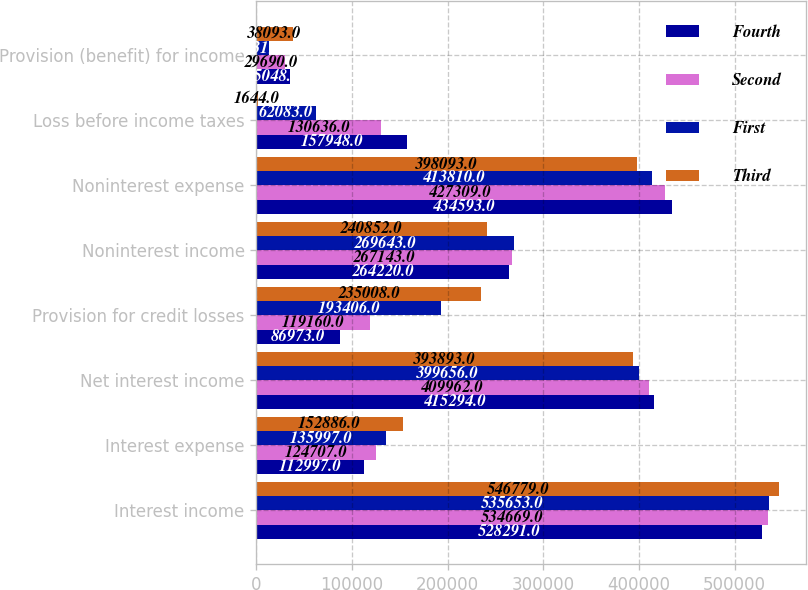<chart> <loc_0><loc_0><loc_500><loc_500><stacked_bar_chart><ecel><fcel>Interest income<fcel>Interest expense<fcel>Net interest income<fcel>Provision for credit losses<fcel>Noninterest income<fcel>Noninterest expense<fcel>Loss before income taxes<fcel>Provision (benefit) for income<nl><fcel>Fourth<fcel>528291<fcel>112997<fcel>415294<fcel>86973<fcel>264220<fcel>434593<fcel>157948<fcel>35048<nl><fcel>Second<fcel>534669<fcel>124707<fcel>409962<fcel>119160<fcel>267143<fcel>427309<fcel>130636<fcel>29690<nl><fcel>First<fcel>535653<fcel>135997<fcel>399656<fcel>193406<fcel>269643<fcel>413810<fcel>62083<fcel>13319<nl><fcel>Third<fcel>546779<fcel>152886<fcel>393893<fcel>235008<fcel>240852<fcel>398093<fcel>1644<fcel>38093<nl></chart> 